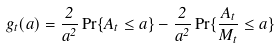Convert formula to latex. <formula><loc_0><loc_0><loc_500><loc_500>g _ { t } ( a ) = \frac { 2 } { a ^ { 2 } } \Pr \{ A _ { t } \leq a \} - \frac { 2 } { a ^ { 2 } } \Pr \{ \frac { A _ { t } } { M _ { t } } \leq a \}</formula> 